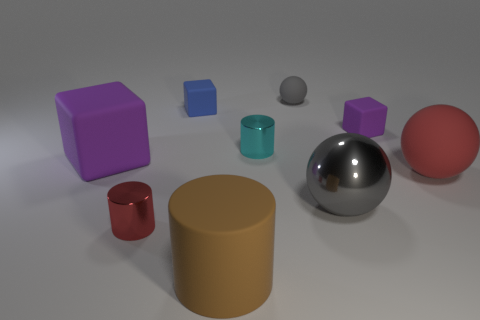Subtract all big red rubber spheres. How many spheres are left? 2 Subtract all green cylinders. How many purple blocks are left? 2 Subtract 1 cylinders. How many cylinders are left? 2 Subtract all balls. How many objects are left? 6 Subtract all blue cylinders. Subtract all red blocks. How many cylinders are left? 3 Subtract 0 yellow cylinders. How many objects are left? 9 Subtract all small cyan cylinders. Subtract all small red shiny things. How many objects are left? 7 Add 7 tiny cubes. How many tiny cubes are left? 9 Add 2 cyan rubber objects. How many cyan rubber objects exist? 2 